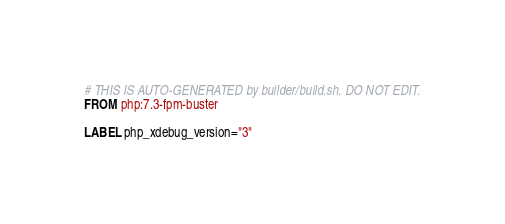Convert code to text. <code><loc_0><loc_0><loc_500><loc_500><_Dockerfile_># THIS IS AUTO-GENERATED by builder/build.sh. DO NOT EDIT.
FROM php:7.3-fpm-buster

LABEL php_xdebug_version="3"
</code> 